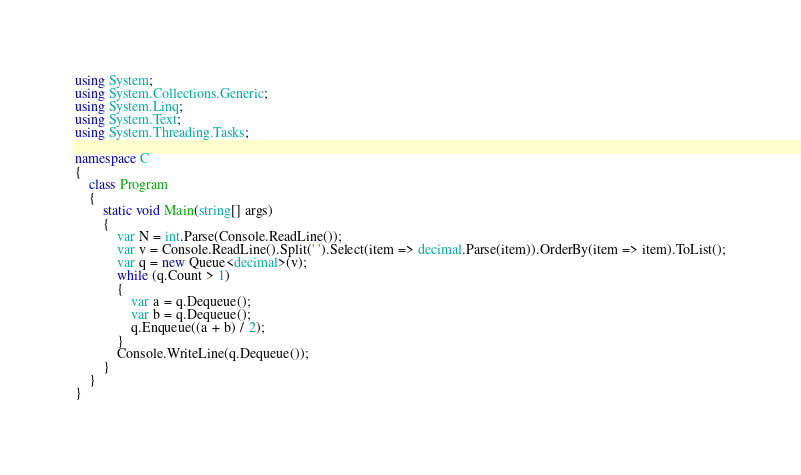Convert code to text. <code><loc_0><loc_0><loc_500><loc_500><_C#_>using System;
using System.Collections.Generic;
using System.Linq;
using System.Text;
using System.Threading.Tasks;

namespace C
{
    class Program
    {
        static void Main(string[] args)
        {
            var N = int.Parse(Console.ReadLine());
            var v = Console.ReadLine().Split(' ').Select(item => decimal.Parse(item)).OrderBy(item => item).ToList();
            var q = new Queue<decimal>(v);
            while (q.Count > 1)
            {
                var a = q.Dequeue();
                var b = q.Dequeue();
                q.Enqueue((a + b) / 2);
            }
            Console.WriteLine(q.Dequeue());
        }
    }
}
</code> 